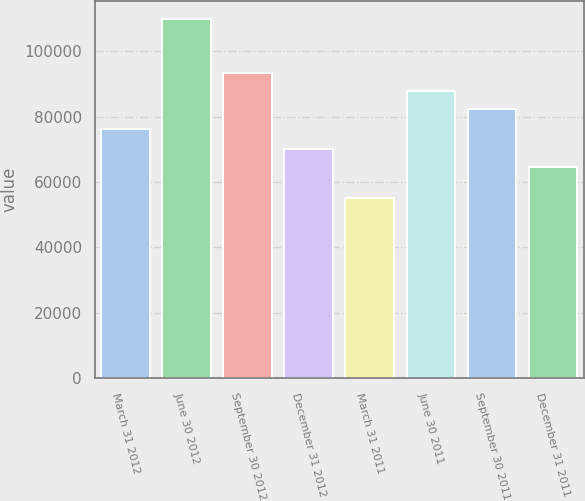Convert chart to OTSL. <chart><loc_0><loc_0><loc_500><loc_500><bar_chart><fcel>March 31 2012<fcel>June 30 2012<fcel>September 30 2012<fcel>December 31 2012<fcel>March 31 2011<fcel>June 30 2011<fcel>September 30 2011<fcel>December 31 2011<nl><fcel>76099<fcel>109795<fcel>93342.4<fcel>70011.2<fcel>55043<fcel>87867.2<fcel>82392<fcel>64536<nl></chart> 